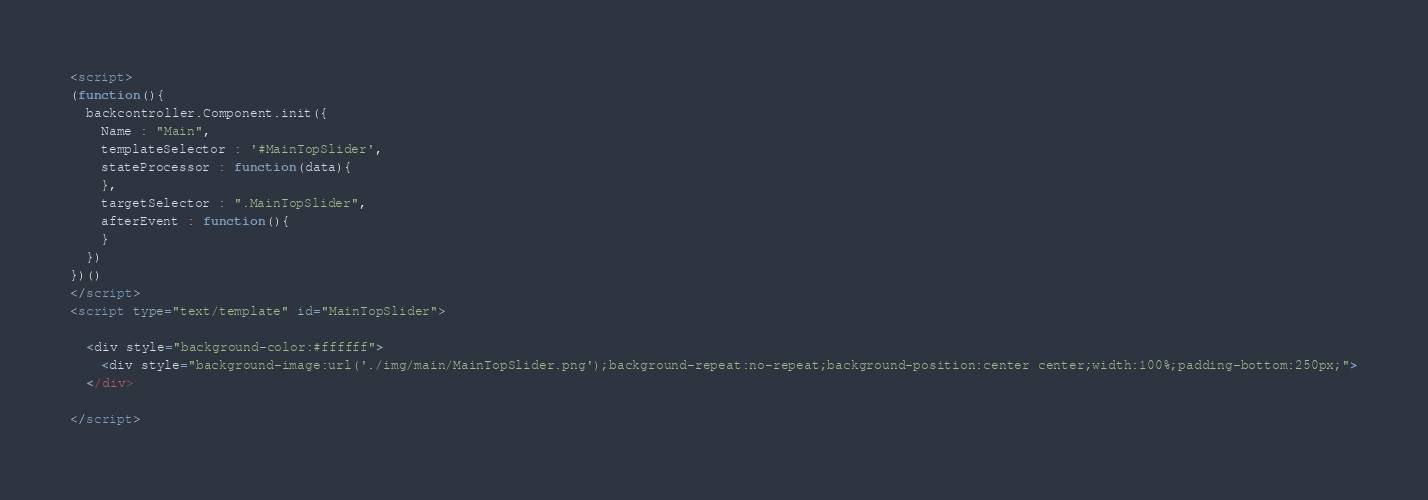<code> <loc_0><loc_0><loc_500><loc_500><_HTML_><script>
(function(){
  backcontroller.Component.init({
    Name : "Main",
    templateSelector : '#MainTopSlider',
    stateProcessor : function(data){
    },
    targetSelector : ".MainTopSlider",
    afterEvent : function(){
    }
  })
})()
</script>
<script type="text/template" id="MainTopSlider">

  <div style="background-color:#ffffff">
    <div style="background-image:url('./img/main/MainTopSlider.png');background-repeat:no-repeat;background-position:center center;width:100%;padding-bottom:250px;">
  </div>

</script>
</code> 